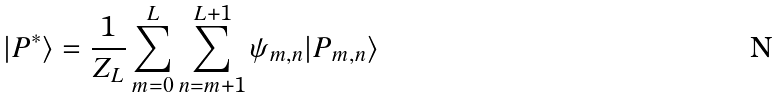Convert formula to latex. <formula><loc_0><loc_0><loc_500><loc_500>| P ^ { \ast } \rangle = \frac { 1 } { Z _ { L } } \sum _ { m = 0 } ^ { L } \sum _ { n = m + 1 } ^ { L + 1 } \psi _ { m , n } | P _ { m , n } \rangle</formula> 